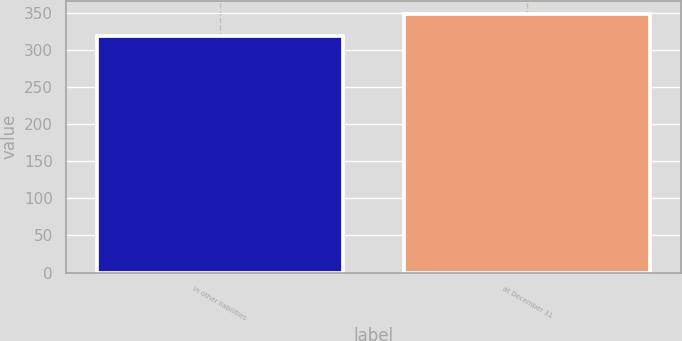Convert chart to OTSL. <chart><loc_0><loc_0><loc_500><loc_500><bar_chart><fcel>in other liabilities<fcel>at December 31<nl><fcel>319<fcel>349<nl></chart> 